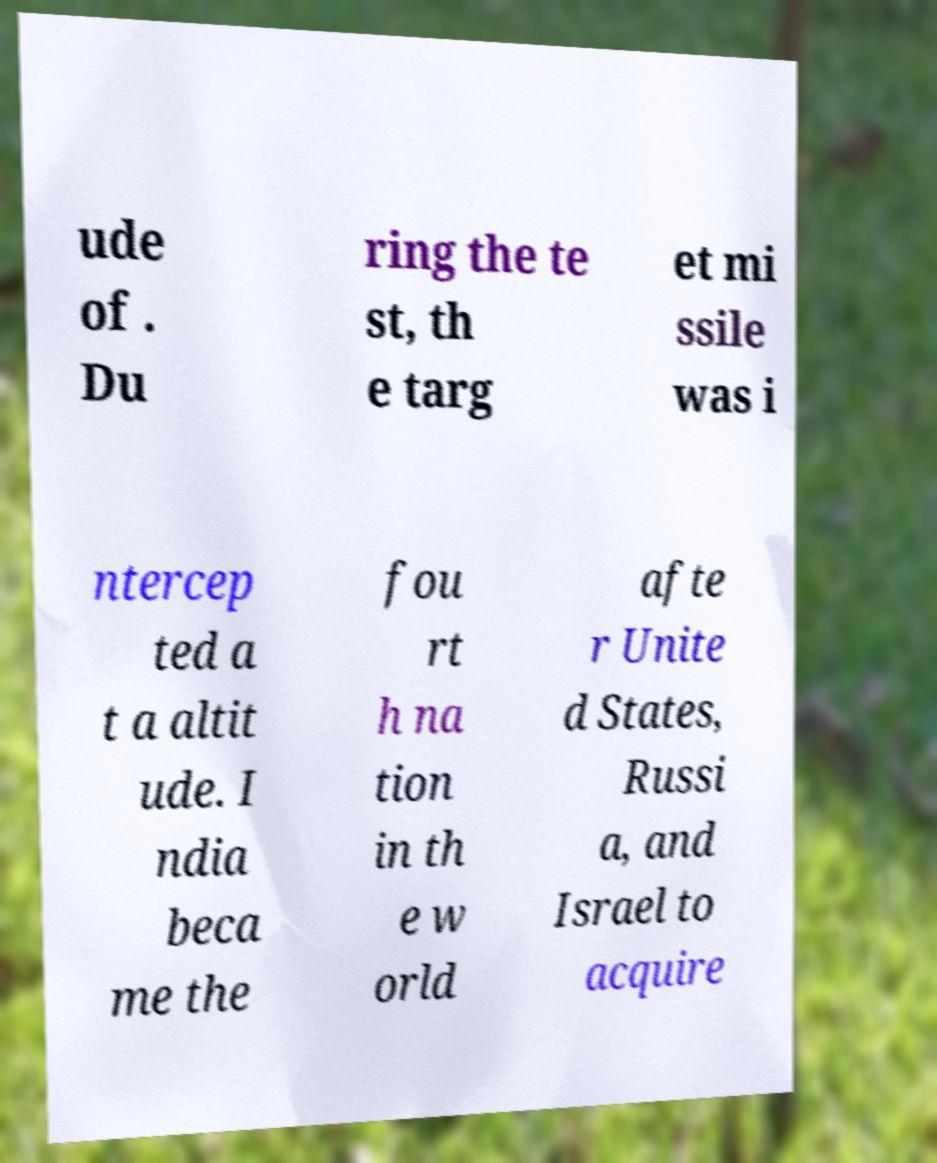Please identify and transcribe the text found in this image. ude of . Du ring the te st, th e targ et mi ssile was i ntercep ted a t a altit ude. I ndia beca me the fou rt h na tion in th e w orld afte r Unite d States, Russi a, and Israel to acquire 